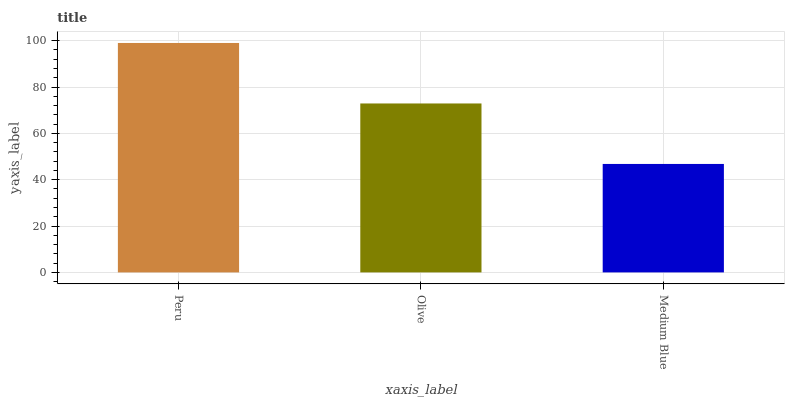Is Medium Blue the minimum?
Answer yes or no. Yes. Is Peru the maximum?
Answer yes or no. Yes. Is Olive the minimum?
Answer yes or no. No. Is Olive the maximum?
Answer yes or no. No. Is Peru greater than Olive?
Answer yes or no. Yes. Is Olive less than Peru?
Answer yes or no. Yes. Is Olive greater than Peru?
Answer yes or no. No. Is Peru less than Olive?
Answer yes or no. No. Is Olive the high median?
Answer yes or no. Yes. Is Olive the low median?
Answer yes or no. Yes. Is Peru the high median?
Answer yes or no. No. Is Peru the low median?
Answer yes or no. No. 